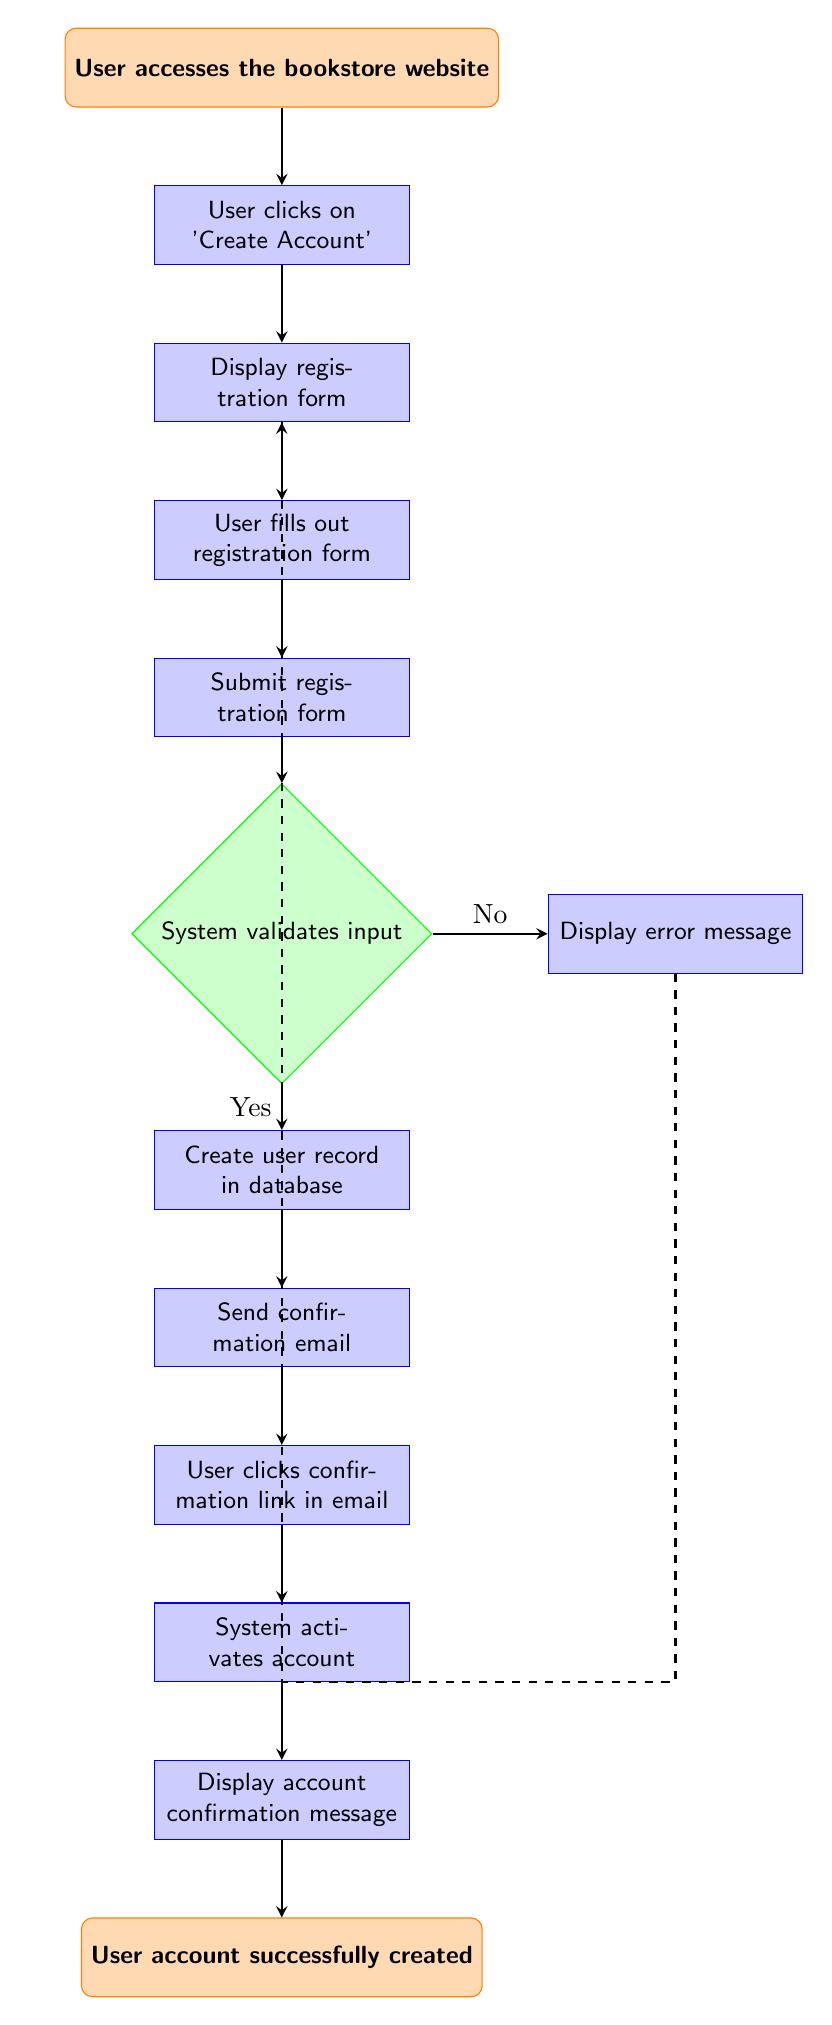What is the first step in the user account creation workflow? The first step is indicated as the starting point of the flow chart. It clearly states that the user accesses the bookstore website.
Answer: User accesses the bookstore website How many steps are there in the workflow before the account confirmation message is displayed? By counting the number of process nodes in the flow that lead to the account confirmation message, we identify that there are eight steps (not including the final message).
Answer: Eight What happens if the system validates the input as invalid? The diagram shows a decision node where if the input is invalid (labeled 'No'), the next step is to display an error message.
Answer: Display error message What action follows after the user clicks the confirmation link in the email? Following the action of the user clicking the confirmation link in the email, the next step indicated in the flow chart is that the system activates the account.
Answer: System activates account How does the diagram signify a successful account creation? The successful account creation is indicated by the final step in the flow chart, which states “User account successfully created”. This serves as the end point of the workflow.
Answer: User account successfully created What is displayed after the system activates the account? After the system activates the account, the next action in the workflow is to display the account confirmation message, as shown in the flow chart.
Answer: Display account confirmation message If a user navigates back after an error message, where do they go next? The diagram illustrates a dashed arrow that indicates that after displaying the error message, the user is directed back to the display registration form to try again.
Answer: Display registration form 